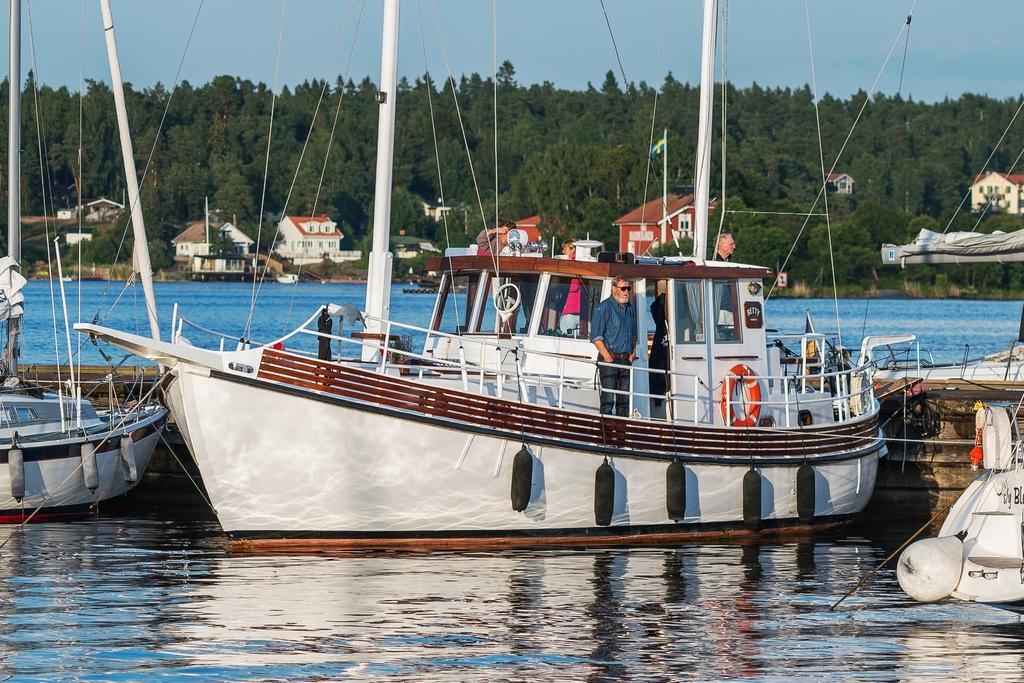Can you describe this image briefly? In this image in front there are people standing on the ship. At the bottom of the image there is water. In the background of the image there are trees and sky. 